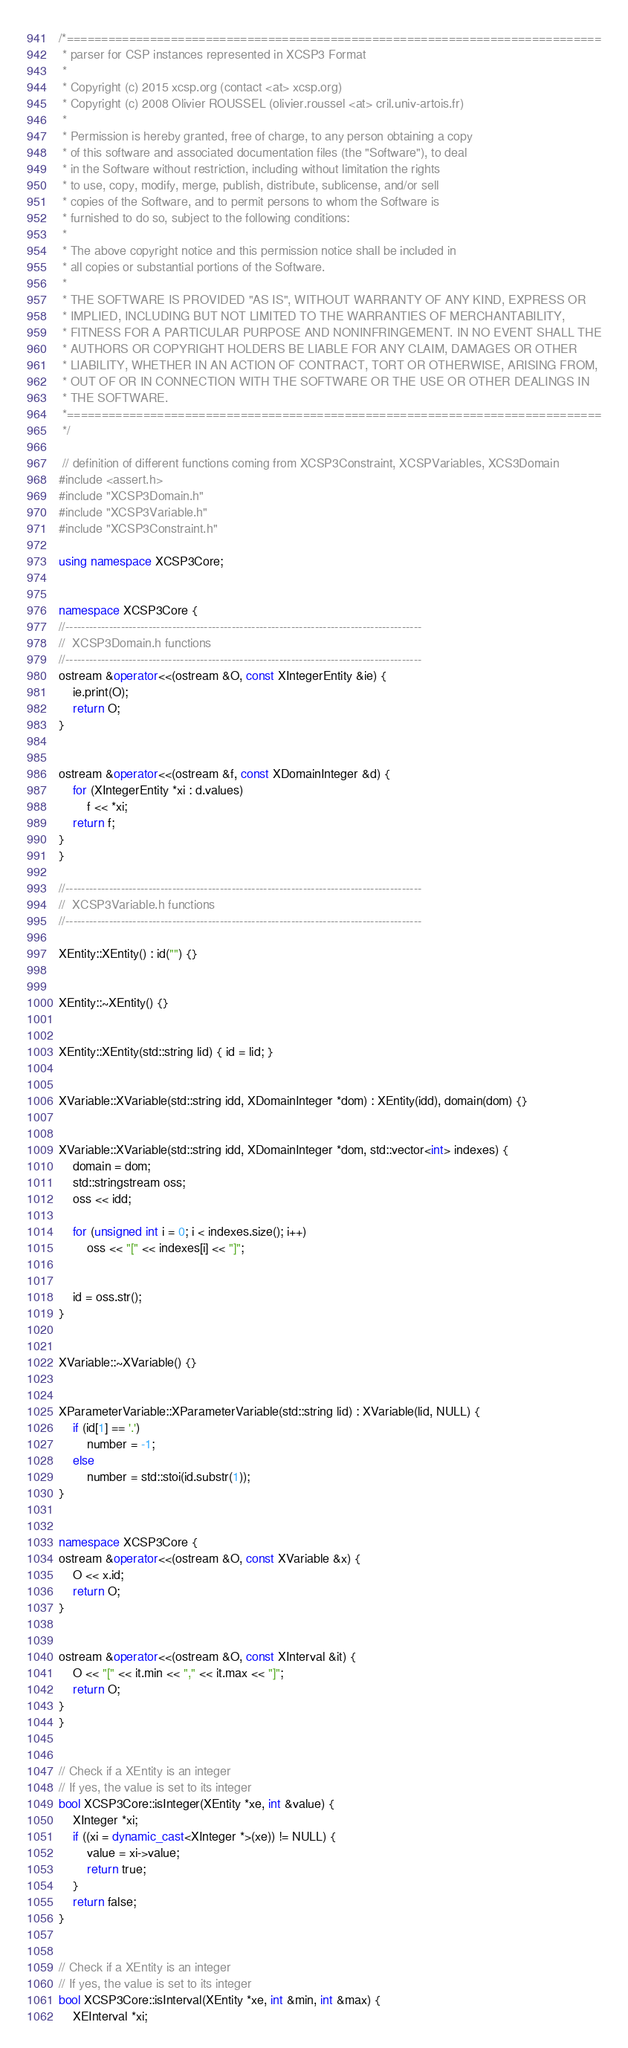Convert code to text. <code><loc_0><loc_0><loc_500><loc_500><_C++_>/*=============================================================================
 * parser for CSP instances represented in XCSP3 Format
 *
 * Copyright (c) 2015 xcsp.org (contact <at> xcsp.org)
 * Copyright (c) 2008 Olivier ROUSSEL (olivier.roussel <at> cril.univ-artois.fr)
 *
 * Permission is hereby granted, free of charge, to any person obtaining a copy
 * of this software and associated documentation files (the "Software"), to deal
 * in the Software without restriction, including without limitation the rights
 * to use, copy, modify, merge, publish, distribute, sublicense, and/or sell
 * copies of the Software, and to permit persons to whom the Software is
 * furnished to do so, subject to the following conditions:
 *
 * The above copyright notice and this permission notice shall be included in
 * all copies or substantial portions of the Software.
 *
 * THE SOFTWARE IS PROVIDED "AS IS", WITHOUT WARRANTY OF ANY KIND, EXPRESS OR
 * IMPLIED, INCLUDING BUT NOT LIMITED TO THE WARRANTIES OF MERCHANTABILITY,
 * FITNESS FOR A PARTICULAR PURPOSE AND NONINFRINGEMENT. IN NO EVENT SHALL THE
 * AUTHORS OR COPYRIGHT HOLDERS BE LIABLE FOR ANY CLAIM, DAMAGES OR OTHER
 * LIABILITY, WHETHER IN AN ACTION OF CONTRACT, TORT OR OTHERWISE, ARISING FROM,
 * OUT OF OR IN CONNECTION WITH THE SOFTWARE OR THE USE OR OTHER DEALINGS IN
 * THE SOFTWARE.
 *=============================================================================
 */

 // definition of different functions coming from XCSP3Constraint, XCSPVariables, XCS3Domain
#include <assert.h>
#include "XCSP3Domain.h"
#include "XCSP3Variable.h"
#include "XCSP3Constraint.h"

using namespace XCSP3Core;


namespace XCSP3Core {
//------------------------------------------------------------------------------------------
//  XCSP3Domain.h functions
//------------------------------------------------------------------------------------------
ostream &operator<<(ostream &O, const XIntegerEntity &ie) {
	ie.print(O);
	return O;
}


ostream &operator<<(ostream &f, const XDomainInteger &d) {
	for (XIntegerEntity *xi : d.values)
		f << *xi;
	return f;
}
}

//------------------------------------------------------------------------------------------
//  XCSP3Variable.h functions
//------------------------------------------------------------------------------------------

XEntity::XEntity() : id("") {}


XEntity::~XEntity() {}


XEntity::XEntity(std::string lid) { id = lid; }


XVariable::XVariable(std::string idd, XDomainInteger *dom) : XEntity(idd), domain(dom) {}


XVariable::XVariable(std::string idd, XDomainInteger *dom, std::vector<int> indexes) {
	domain = dom;
	std::stringstream oss;
	oss << idd;

	for (unsigned int i = 0; i < indexes.size(); i++)
		oss << "[" << indexes[i] << "]";


	id = oss.str();
}


XVariable::~XVariable() {}


XParameterVariable::XParameterVariable(std::string lid) : XVariable(lid, NULL) {
	if (id[1] == '.')
		number = -1;
	else
		number = std::stoi(id.substr(1));
}


namespace XCSP3Core {
ostream &operator<<(ostream &O, const XVariable &x) {
	O << x.id;
	return O;
}


ostream &operator<<(ostream &O, const XInterval &it) {
	O << "[" << it.min << "," << it.max << "]";
	return O;
}
}


// Check if a XEntity is an integer
// If yes, the value is set to its integer
bool XCSP3Core::isInteger(XEntity *xe, int &value) {
	XInteger *xi;
	if ((xi = dynamic_cast<XInteger *>(xe)) != NULL) {
		value = xi->value;
		return true;
	}
	return false;
}


// Check if a XEntity is an integer
// If yes, the value is set to its integer
bool XCSP3Core::isInterval(XEntity *xe, int &min, int &max) {
	XEInterval *xi;</code> 